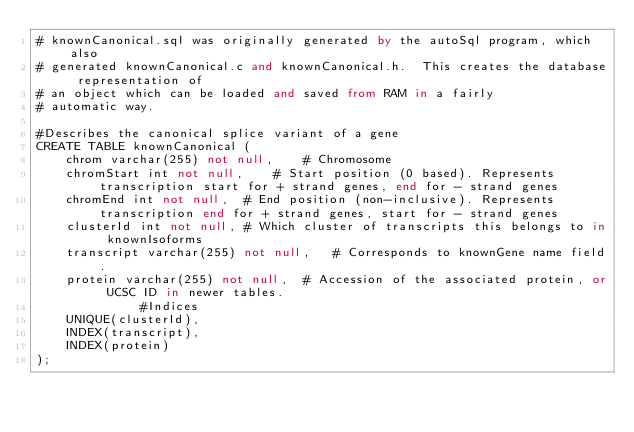Convert code to text. <code><loc_0><loc_0><loc_500><loc_500><_SQL_># knownCanonical.sql was originally generated by the autoSql program, which also 
# generated knownCanonical.c and knownCanonical.h.  This creates the database representation of
# an object which can be loaded and saved from RAM in a fairly 
# automatic way.

#Describes the canonical splice variant of a gene
CREATE TABLE knownCanonical (
    chrom varchar(255) not null,	# Chromosome
    chromStart int not null,	# Start position (0 based). Represents transcription start for + strand genes, end for - strand genes
    chromEnd int not null,	# End position (non-inclusive). Represents transcription end for + strand genes, start for - strand genes
    clusterId int not null,	# Which cluster of transcripts this belongs to in knownIsoforms
    transcript varchar(255) not null,	# Corresponds to knownGene name field.
    protein varchar(255) not null,	# Accession of the associated protein, or UCSC ID in newer tables.
              #Indices
    UNIQUE(clusterId),
    INDEX(transcript),
    INDEX(protein)
);
</code> 